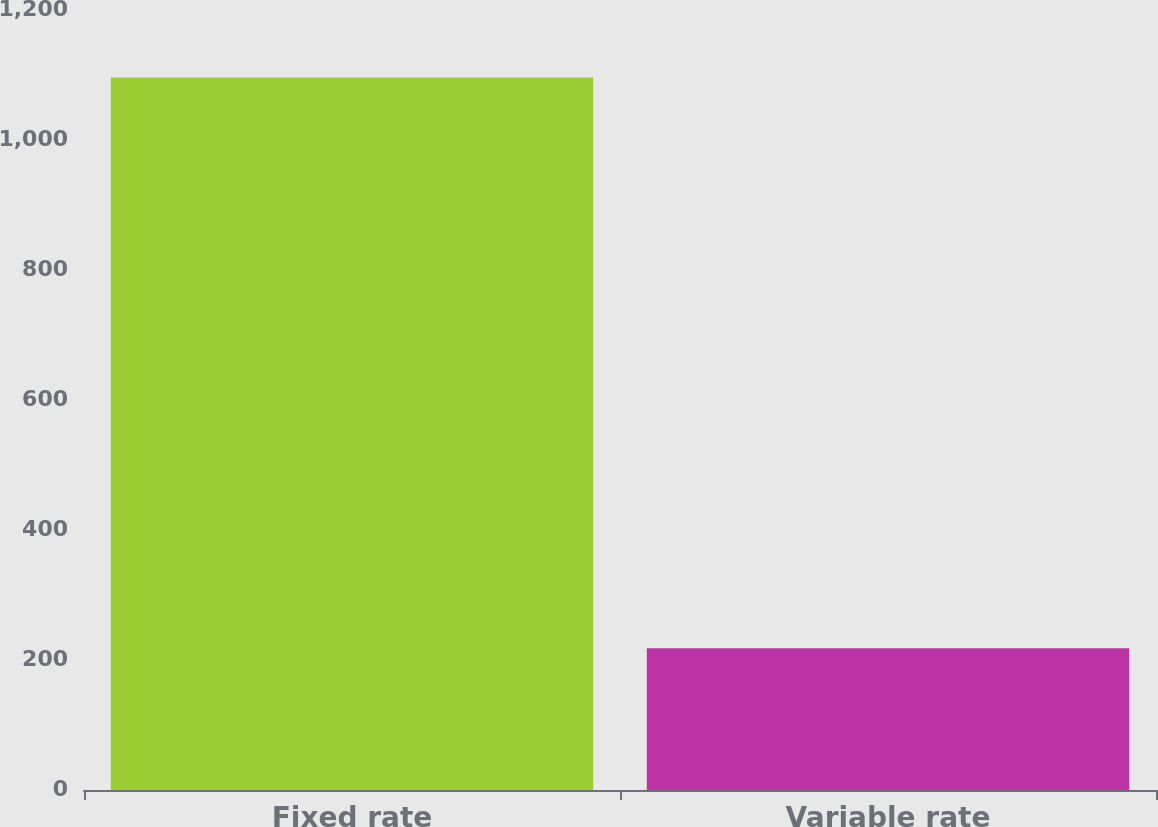Convert chart. <chart><loc_0><loc_0><loc_500><loc_500><bar_chart><fcel>Fixed rate<fcel>Variable rate<nl><fcel>1096.2<fcel>217.9<nl></chart> 